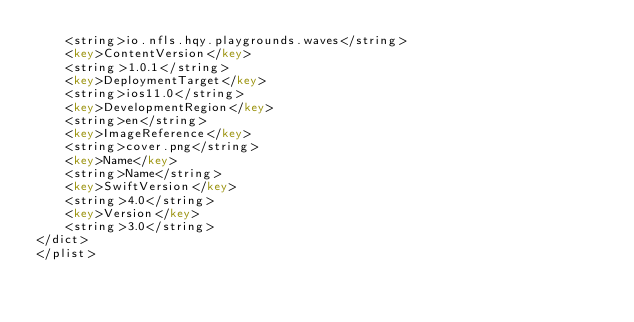Convert code to text. <code><loc_0><loc_0><loc_500><loc_500><_XML_>	<string>io.nfls.hqy.playgrounds.waves</string>
	<key>ContentVersion</key>
	<string>1.0.1</string>
	<key>DeploymentTarget</key>
	<string>ios11.0</string>
	<key>DevelopmentRegion</key>
	<string>en</string>
	<key>ImageReference</key>
	<string>cover.png</string>
	<key>Name</key>
	<string>Name</string>
	<key>SwiftVersion</key>
	<string>4.0</string>
	<key>Version</key>
	<string>3.0</string>
</dict>
</plist>
</code> 